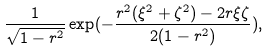Convert formula to latex. <formula><loc_0><loc_0><loc_500><loc_500>\frac { 1 } { \sqrt { 1 - r ^ { 2 } } } \exp ( - \frac { r ^ { 2 } ( \xi ^ { 2 } + \zeta ^ { 2 } ) - 2 r \xi \zeta } { 2 ( 1 - r ^ { 2 } ) } ) ,</formula> 